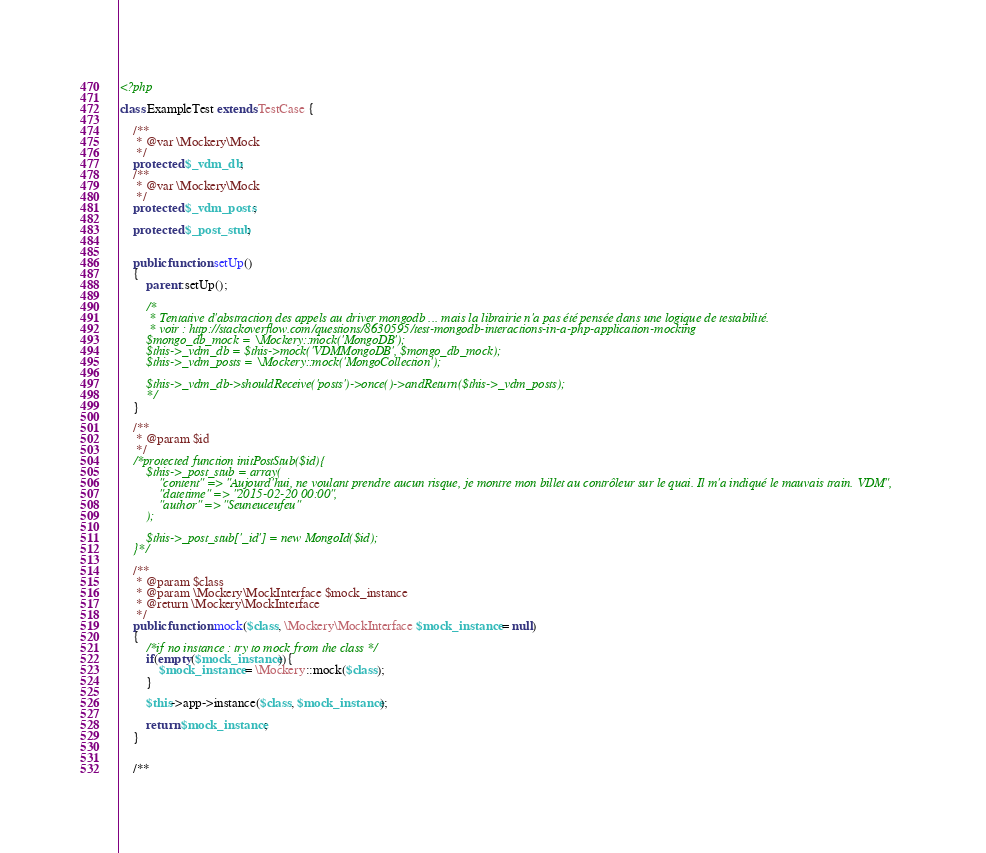<code> <loc_0><loc_0><loc_500><loc_500><_PHP_><?php

class ExampleTest extends TestCase {

	/**
	 * @var \Mockery\Mock
	 */
	protected $_vdm_db;
	/**
	 * @var \Mockery\Mock
	 */
	protected $_vdm_posts;

	protected $_post_stub;


	public function setUp()
	{
		parent::setUp();

		/*
		 * Tentative d'abstraction des appels au driver mongodb ... mais la librairie n'a pas été pensée dans une logique de testabilité.
		 * voir : http://stackoverflow.com/questions/8630595/test-mongodb-interactions-in-a-php-application-mocking
		$mongo_db_mock = \Mockery::mock('MongoDB');
		$this->_vdm_db = $this->mock('VDMMongoDB', $mongo_db_mock);
		$this->_vdm_posts = \Mockery::mock('MongoCollection');

		$this->_vdm_db->shouldReceive('posts')->once()->andReturn($this->_vdm_posts);
		*/
	}

	/**
	 * @param $id
	 */
	/*protected function initPostStub($id){
		$this->_post_stub = array(
			"content" => "Aujourd'hui, ne voulant prendre aucun risque, je montre mon billet au contrôleur sur le quai. Il m'a indiqué le mauvais train. VDM",
        	"datetime" => "2015-02-20 00:00",
        	"author" => "Seuneuceufeu"
		);

		$this->_post_stub['_id'] = new MongoId($id);
	}*/

	/**
	 * @param $class
	 * @param \Mockery\MockInterface $mock_instance
	 * @return \Mockery\MockInterface
	 */
	public function mock($class, \Mockery\MockInterface $mock_instance = null)
	{
		/*if no instance : try to mock from the class */
		if(empty($mock_instance)){
			$mock_instance = \Mockery::mock($class);
		}

		$this->app->instance($class, $mock_instance);

		return $mock_instance;
	}


	/**</code> 